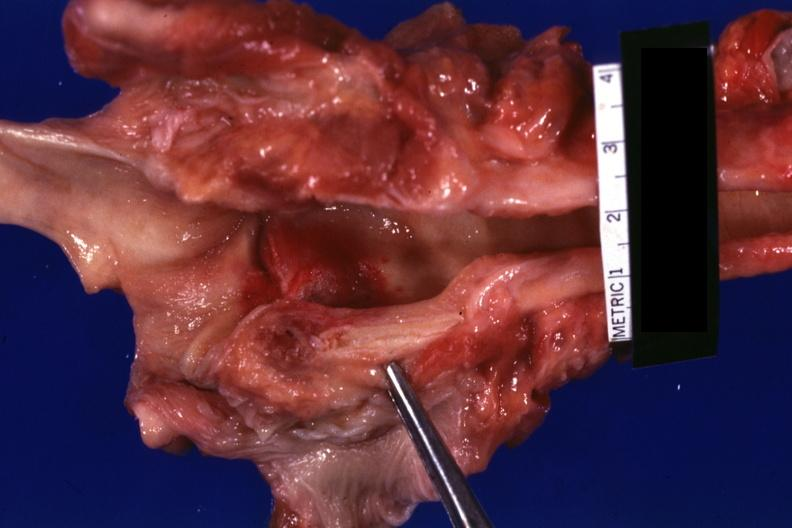what is present?
Answer the question using a single word or phrase. Ulcer with candida infection 